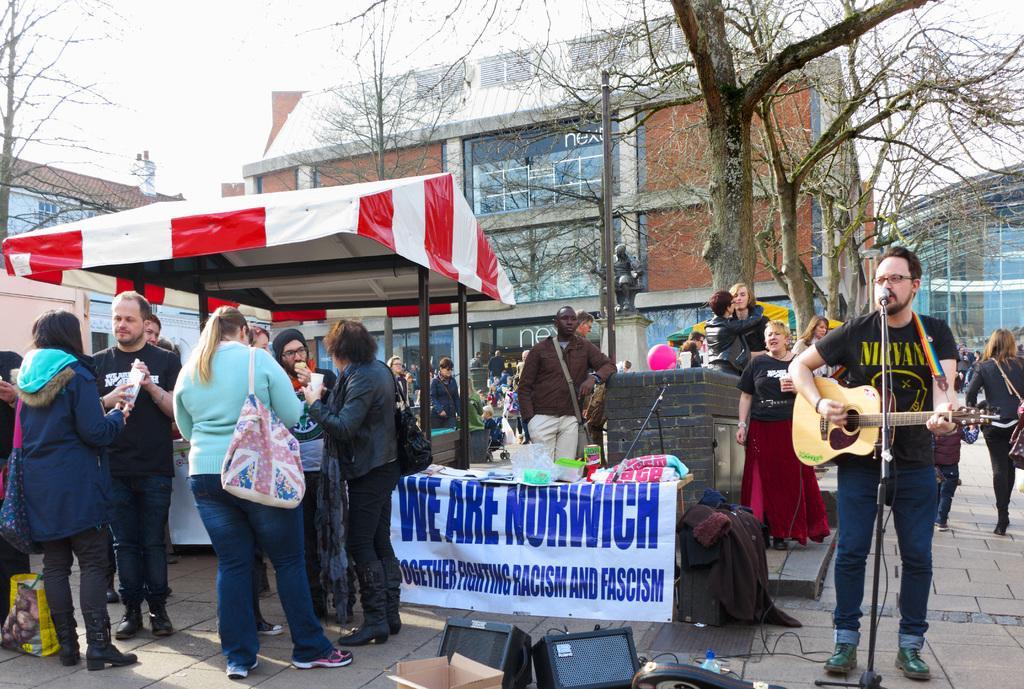In one or two sentences, can you explain what this image depicts? In this image there are group of people who are standing on the right side there is one person who is standing and he is holding a guitar in front of him there is one mike, and he is wearing black shirt and in the middle of the image there is one building and trees are there. And on the top of the left corner there is sky and in the middle of the image there is one tent and on the floor there are some lights, box, and one poster is there and in the middle of the image there is one pole and statue are there. 